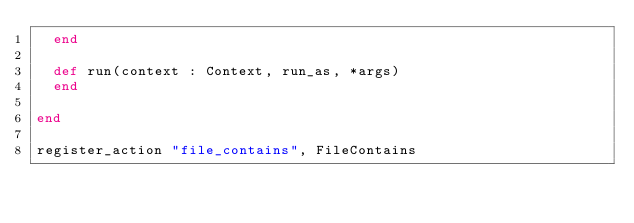<code> <loc_0><loc_0><loc_500><loc_500><_Crystal_>  end

  def run(context : Context, run_as, *args)
  end

end

register_action "file_contains", FileContains
</code> 